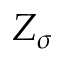<formula> <loc_0><loc_0><loc_500><loc_500>Z _ { \sigma }</formula> 